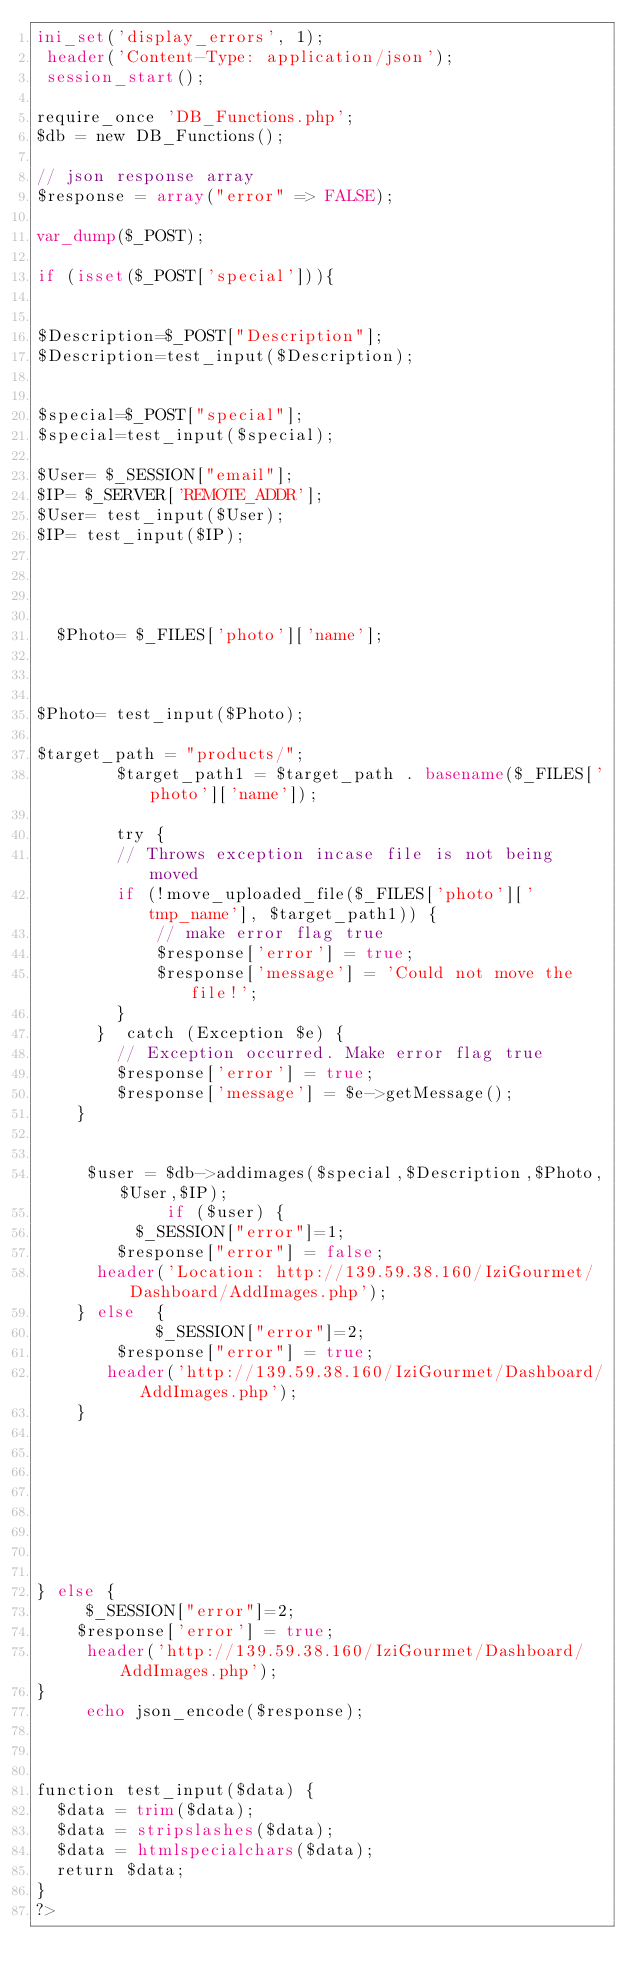Convert code to text. <code><loc_0><loc_0><loc_500><loc_500><_PHP_>ini_set('display_errors', 1);
 header('Content-Type: application/json');
 session_start();

require_once 'DB_Functions.php';
$db = new DB_Functions();
 
// json response array
$response = array("error" => FALSE);

var_dump($_POST);

if (isset($_POST['special'])){


$Description=$_POST["Description"];
$Description=test_input($Description);


$special=$_POST["special"];
$special=test_input($special);

$User= $_SESSION["email"];
$IP= $_SERVER['REMOTE_ADDR'];
$User= test_input($User);
$IP= test_input($IP);




  $Photo= $_FILES['photo']['name'];



$Photo= test_input($Photo);

$target_path = "products/";
        $target_path1 = $target_path . basename($_FILES['photo']['name']);
      
        try {
        // Throws exception incase file is not being moved
        if (!move_uploaded_file($_FILES['photo']['tmp_name'], $target_path1)) {
            // make error flag true
            $response['error'] = true;
            $response['message'] = 'Could not move the file!';
        }
      }  catch (Exception $e) {
        // Exception occurred. Make error flag true
        $response['error'] = true;
        $response['message'] = $e->getMessage();
    }


     $user = $db->addimages($special,$Description,$Photo,$User,$IP);
             if ($user) {  
          $_SESSION["error"]=1;
        $response["error"] = false;
      header('Location: http://139.59.38.160/IziGourmet/Dashboard/AddImages.php');
    } else  {
            $_SESSION["error"]=2;
        $response["error"] = true;
       header('http://139.59.38.160/IziGourmet/Dashboard/AddImages.php');
    }

 
 

    



} else {
     $_SESSION["error"]=2;
    $response['error'] = true;
     header('http://139.59.38.160/IziGourmet/Dashboard/AddImages.php');
}
     echo json_encode($response); 
       


function test_input($data) {
  $data = trim($data);
  $data = stripslashes($data);
  $data = htmlspecialchars($data);
  return $data;
}
?></code> 